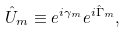Convert formula to latex. <formula><loc_0><loc_0><loc_500><loc_500>\hat { U } _ { m } \equiv e ^ { i \gamma _ { m } } e ^ { i \hat { \Gamma } _ { m } } ,</formula> 